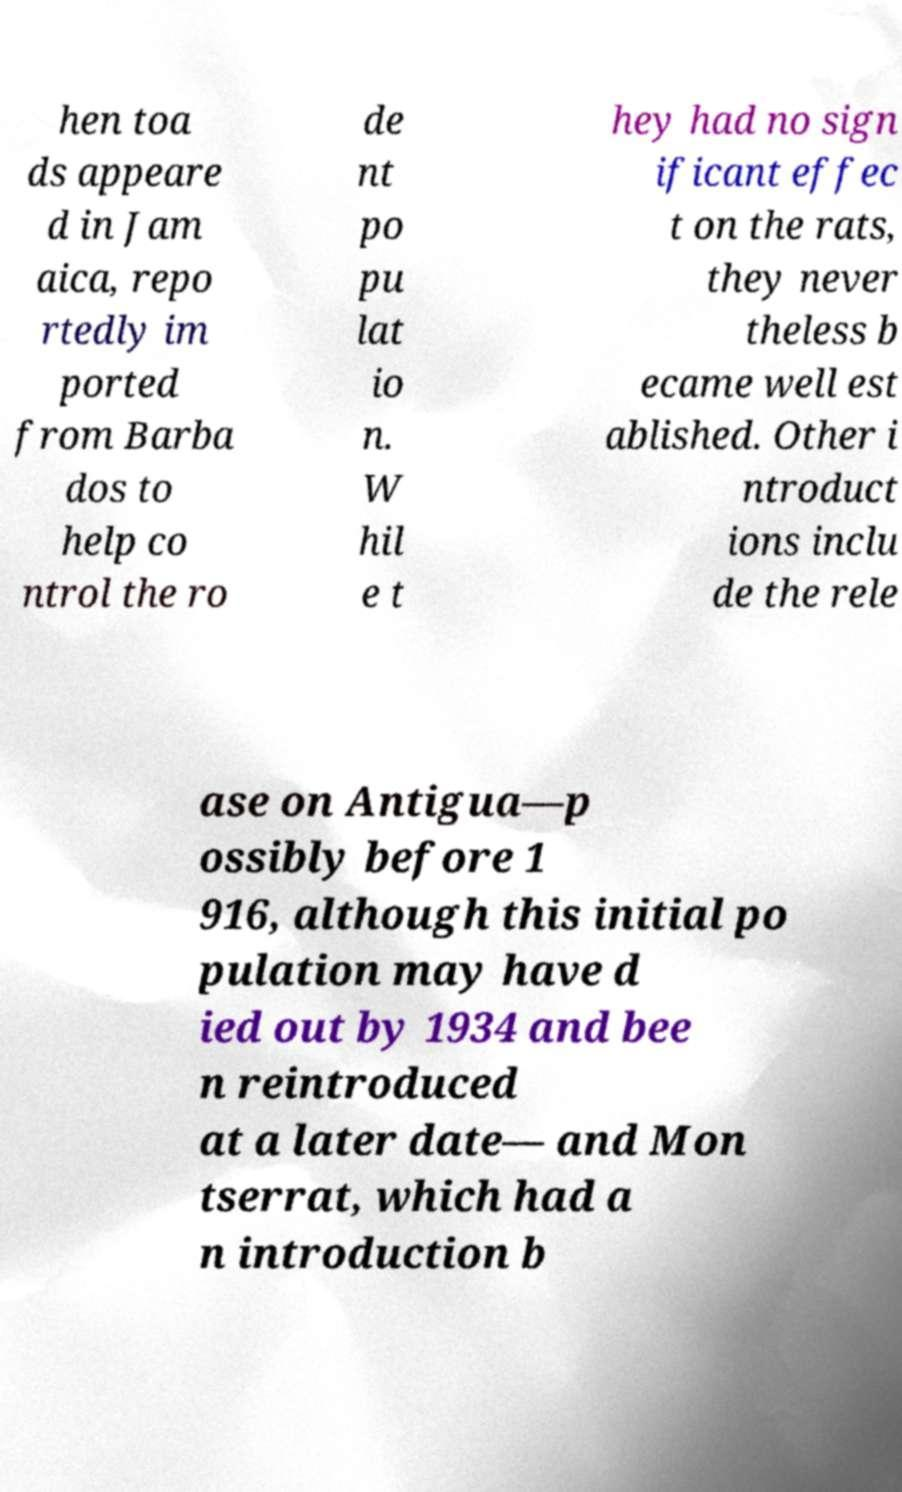What messages or text are displayed in this image? I need them in a readable, typed format. hen toa ds appeare d in Jam aica, repo rtedly im ported from Barba dos to help co ntrol the ro de nt po pu lat io n. W hil e t hey had no sign ificant effec t on the rats, they never theless b ecame well est ablished. Other i ntroduct ions inclu de the rele ase on Antigua—p ossibly before 1 916, although this initial po pulation may have d ied out by 1934 and bee n reintroduced at a later date— and Mon tserrat, which had a n introduction b 